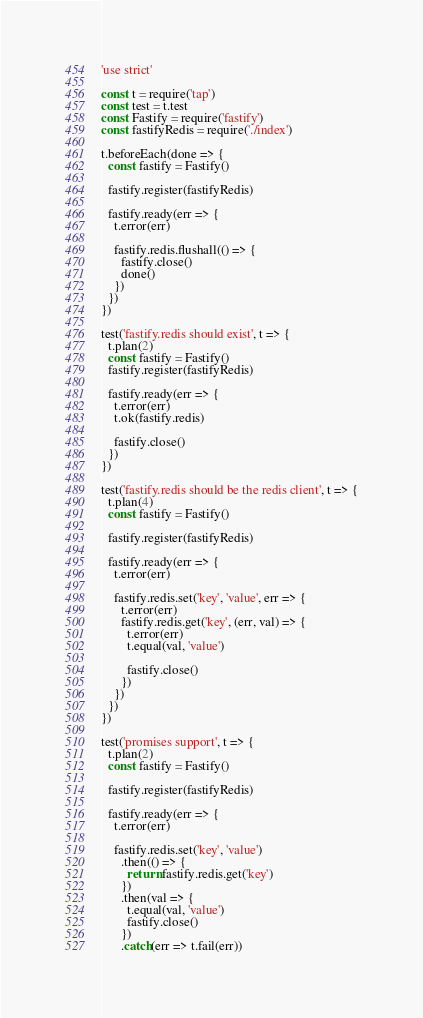<code> <loc_0><loc_0><loc_500><loc_500><_JavaScript_>'use strict'

const t = require('tap')
const test = t.test
const Fastify = require('fastify')
const fastifyRedis = require('./index')

t.beforeEach(done => {
  const fastify = Fastify()

  fastify.register(fastifyRedis)

  fastify.ready(err => {
    t.error(err)

    fastify.redis.flushall(() => {
      fastify.close()
      done()
    })
  })
})

test('fastify.redis should exist', t => {
  t.plan(2)
  const fastify = Fastify()
  fastify.register(fastifyRedis)

  fastify.ready(err => {
    t.error(err)
    t.ok(fastify.redis)

    fastify.close()
  })
})

test('fastify.redis should be the redis client', t => {
  t.plan(4)
  const fastify = Fastify()

  fastify.register(fastifyRedis)

  fastify.ready(err => {
    t.error(err)

    fastify.redis.set('key', 'value', err => {
      t.error(err)
      fastify.redis.get('key', (err, val) => {
        t.error(err)
        t.equal(val, 'value')

        fastify.close()
      })
    })
  })
})

test('promises support', t => {
  t.plan(2)
  const fastify = Fastify()

  fastify.register(fastifyRedis)

  fastify.ready(err => {
    t.error(err)

    fastify.redis.set('key', 'value')
      .then(() => {
        return fastify.redis.get('key')
      })
      .then(val => {
        t.equal(val, 'value')
        fastify.close()
      })
      .catch(err => t.fail(err))</code> 